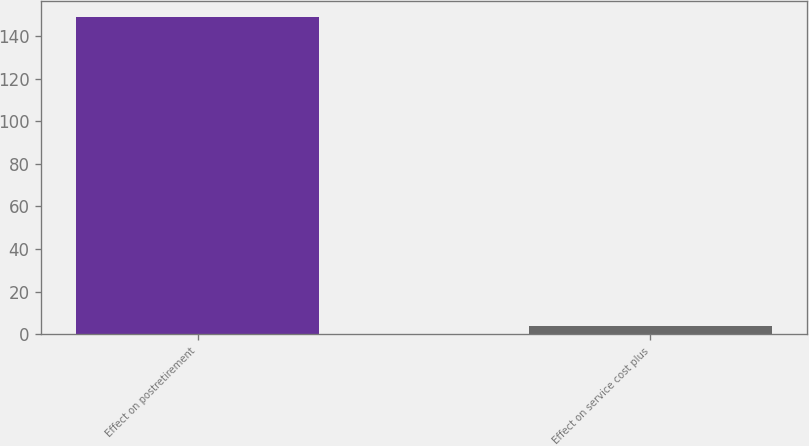<chart> <loc_0><loc_0><loc_500><loc_500><bar_chart><fcel>Effect on postretirement<fcel>Effect on service cost plus<nl><fcel>149<fcel>4<nl></chart> 